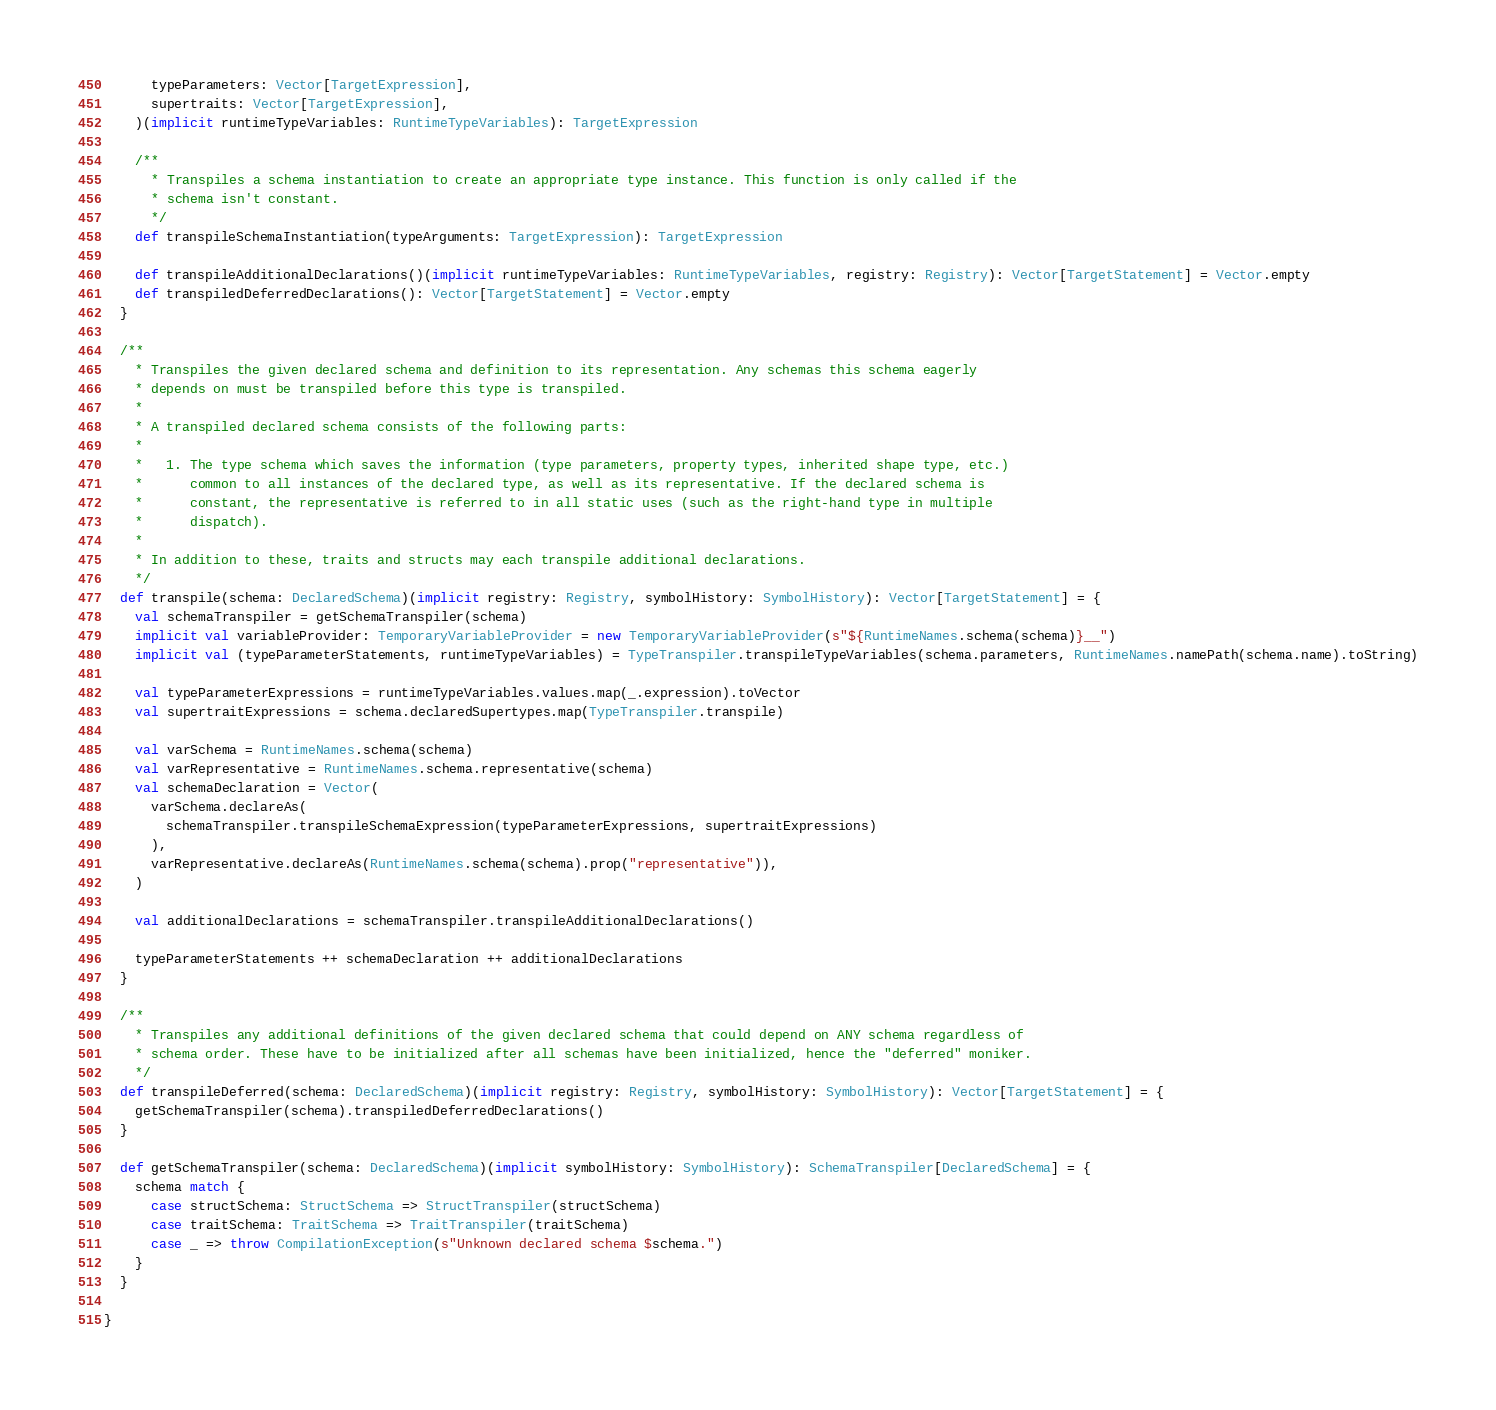Convert code to text. <code><loc_0><loc_0><loc_500><loc_500><_Scala_>      typeParameters: Vector[TargetExpression],
      supertraits: Vector[TargetExpression],
    )(implicit runtimeTypeVariables: RuntimeTypeVariables): TargetExpression

    /**
      * Transpiles a schema instantiation to create an appropriate type instance. This function is only called if the
      * schema isn't constant.
      */
    def transpileSchemaInstantiation(typeArguments: TargetExpression): TargetExpression

    def transpileAdditionalDeclarations()(implicit runtimeTypeVariables: RuntimeTypeVariables, registry: Registry): Vector[TargetStatement] = Vector.empty
    def transpiledDeferredDeclarations(): Vector[TargetStatement] = Vector.empty
  }

  /**
    * Transpiles the given declared schema and definition to its representation. Any schemas this schema eagerly
    * depends on must be transpiled before this type is transpiled.
    *
    * A transpiled declared schema consists of the following parts:
    *
    *   1. The type schema which saves the information (type parameters, property types, inherited shape type, etc.)
    *      common to all instances of the declared type, as well as its representative. If the declared schema is
    *      constant, the representative is referred to in all static uses (such as the right-hand type in multiple
    *      dispatch).
    *
    * In addition to these, traits and structs may each transpile additional declarations.
    */
  def transpile(schema: DeclaredSchema)(implicit registry: Registry, symbolHistory: SymbolHistory): Vector[TargetStatement] = {
    val schemaTranspiler = getSchemaTranspiler(schema)
    implicit val variableProvider: TemporaryVariableProvider = new TemporaryVariableProvider(s"${RuntimeNames.schema(schema)}__")
    implicit val (typeParameterStatements, runtimeTypeVariables) = TypeTranspiler.transpileTypeVariables(schema.parameters, RuntimeNames.namePath(schema.name).toString)

    val typeParameterExpressions = runtimeTypeVariables.values.map(_.expression).toVector
    val supertraitExpressions = schema.declaredSupertypes.map(TypeTranspiler.transpile)

    val varSchema = RuntimeNames.schema(schema)
    val varRepresentative = RuntimeNames.schema.representative(schema)
    val schemaDeclaration = Vector(
      varSchema.declareAs(
        schemaTranspiler.transpileSchemaExpression(typeParameterExpressions, supertraitExpressions)
      ),
      varRepresentative.declareAs(RuntimeNames.schema(schema).prop("representative")),
    )

    val additionalDeclarations = schemaTranspiler.transpileAdditionalDeclarations()

    typeParameterStatements ++ schemaDeclaration ++ additionalDeclarations
  }

  /**
    * Transpiles any additional definitions of the given declared schema that could depend on ANY schema regardless of
    * schema order. These have to be initialized after all schemas have been initialized, hence the "deferred" moniker.
    */
  def transpileDeferred(schema: DeclaredSchema)(implicit registry: Registry, symbolHistory: SymbolHistory): Vector[TargetStatement] = {
    getSchemaTranspiler(schema).transpiledDeferredDeclarations()
  }

  def getSchemaTranspiler(schema: DeclaredSchema)(implicit symbolHistory: SymbolHistory): SchemaTranspiler[DeclaredSchema] = {
    schema match {
      case structSchema: StructSchema => StructTranspiler(structSchema)
      case traitSchema: TraitSchema => TraitTranspiler(traitSchema)
      case _ => throw CompilationException(s"Unknown declared schema $schema.")
    }
  }

}
</code> 